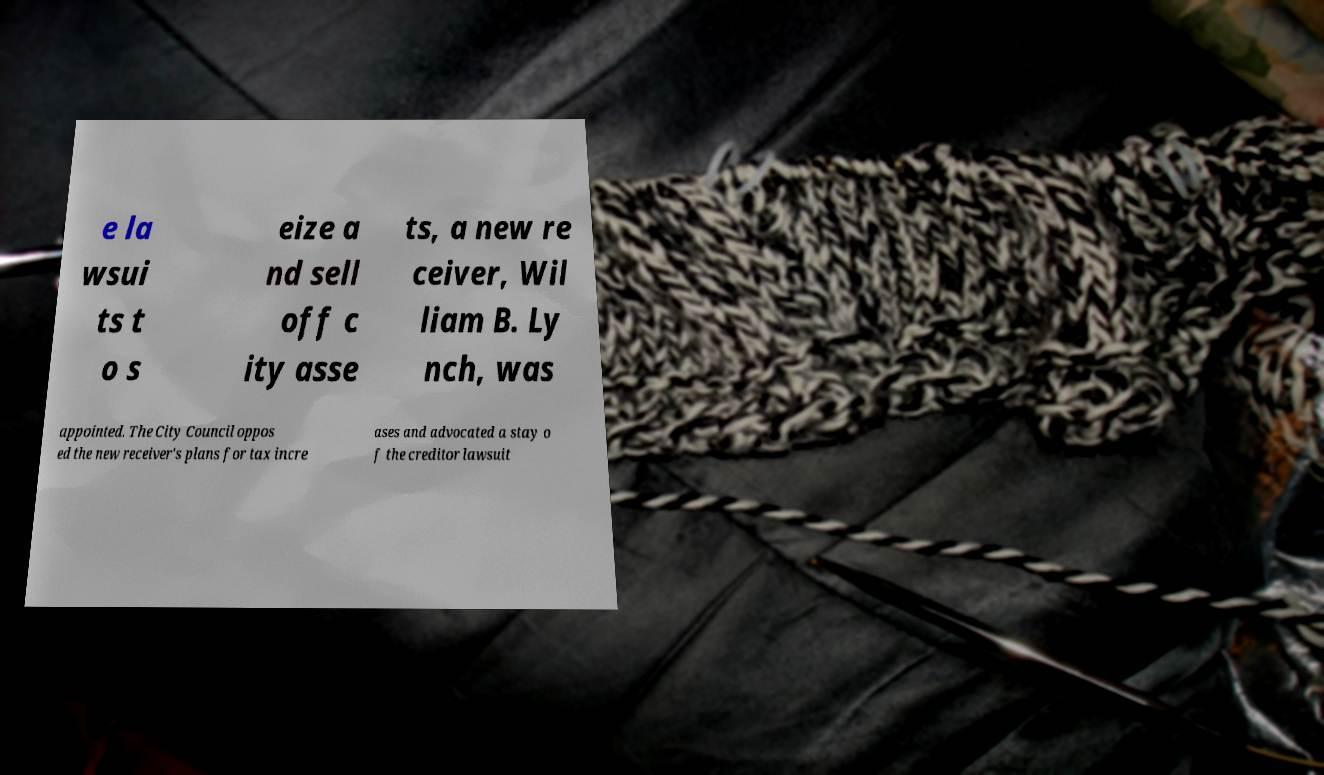Please identify and transcribe the text found in this image. e la wsui ts t o s eize a nd sell off c ity asse ts, a new re ceiver, Wil liam B. Ly nch, was appointed. The City Council oppos ed the new receiver's plans for tax incre ases and advocated a stay o f the creditor lawsuit 